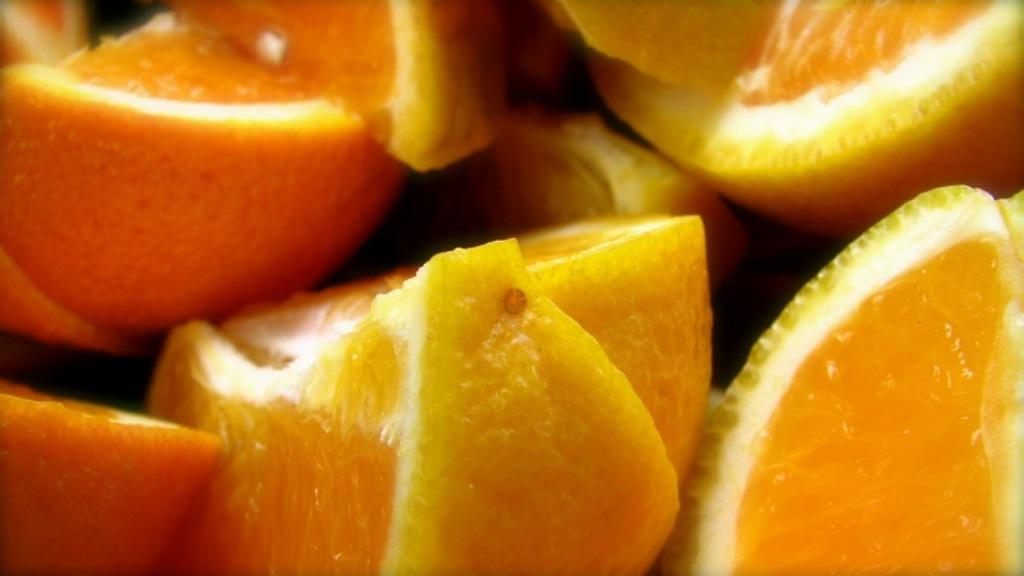What type of food can be seen in the image? There are fruits in the image. What color are the fruits in the image? The fruits are in yellow color. What type of tooth is visible in the image? There is no tooth visible in the image; it features yellow fruits. What is being distributed in the image? There is no distribution activity depicted in the image; it only shows yellow fruits. 